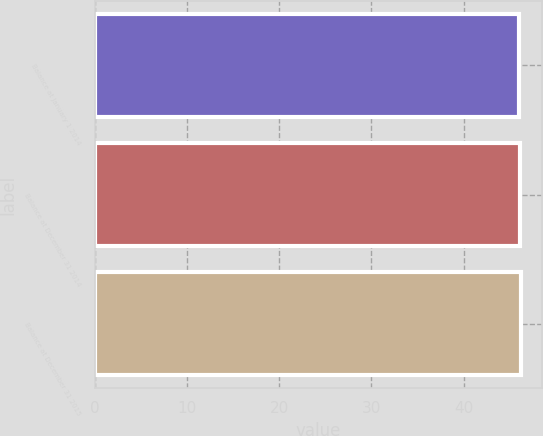Convert chart. <chart><loc_0><loc_0><loc_500><loc_500><bar_chart><fcel>Balance at January 1 2014<fcel>Balance at December 31 2014<fcel>Balance at December 31 2015<nl><fcel>46<fcel>46.1<fcel>46.2<nl></chart> 